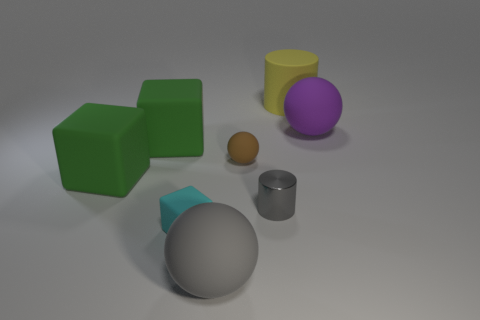Are there any cylinders in front of the big sphere behind the big sphere left of the purple rubber ball?
Provide a short and direct response. Yes. What size is the gray metal cylinder?
Keep it short and to the point. Small. How many objects are big metallic things or large green rubber cubes?
Your response must be concise. 2. What is the color of the small block that is made of the same material as the yellow cylinder?
Make the answer very short. Cyan. There is a gray object in front of the small cyan thing; is it the same shape as the small metallic object?
Offer a very short reply. No. How many objects are either big things that are behind the purple thing or objects that are on the right side of the small cyan block?
Provide a succinct answer. 5. What color is the other object that is the same shape as the big yellow thing?
Make the answer very short. Gray. Is there any other thing that has the same shape as the tiny brown rubber object?
Your answer should be compact. Yes. There is a cyan rubber object; does it have the same shape as the rubber thing that is right of the rubber cylinder?
Keep it short and to the point. No. What material is the large cylinder?
Provide a short and direct response. Rubber. 